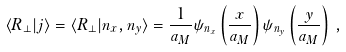<formula> <loc_0><loc_0><loc_500><loc_500>\langle { R } _ { \perp } | j \rangle = \langle { R } _ { \perp } | n _ { x } , n _ { y } \rangle = \frac { 1 } { a _ { M } } \psi _ { n _ { x } } \left ( \frac { x } { a _ { M } } \right ) \psi _ { n _ { y } } \left ( \frac { y } { a _ { M } } \right ) \, ,</formula> 